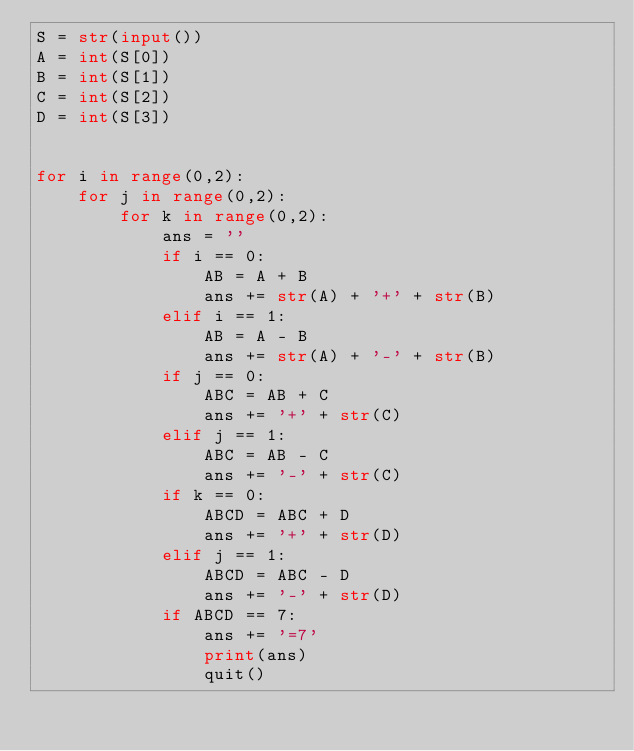<code> <loc_0><loc_0><loc_500><loc_500><_Python_>S = str(input())
A = int(S[0])
B = int(S[1])
C = int(S[2])
D = int(S[3])


for i in range(0,2):
    for j in range(0,2):
        for k in range(0,2):
            ans = ''
            if i == 0:
                AB = A + B
                ans += str(A) + '+' + str(B)
            elif i == 1:
                AB = A - B
                ans += str(A) + '-' + str(B)
            if j == 0:
                ABC = AB + C
                ans += '+' + str(C)
            elif j == 1:
                ABC = AB - C
                ans += '-' + str(C)
            if k == 0:
                ABCD = ABC + D
                ans += '+' + str(D)
            elif j == 1:
                ABCD = ABC - D
                ans += '-' + str(D)
            if ABCD == 7:
                ans += '=7'
                print(ans)
                quit()</code> 